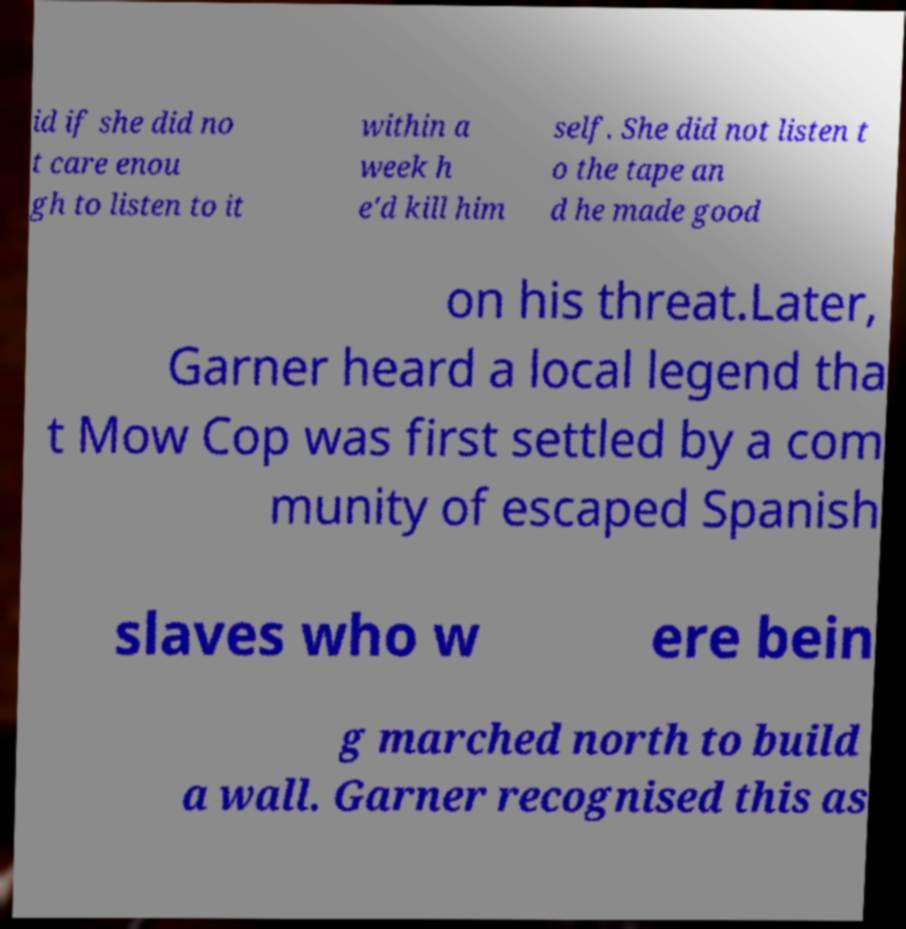Could you extract and type out the text from this image? id if she did no t care enou gh to listen to it within a week h e'd kill him self. She did not listen t o the tape an d he made good on his threat.Later, Garner heard a local legend tha t Mow Cop was first settled by a com munity of escaped Spanish slaves who w ere bein g marched north to build a wall. Garner recognised this as 